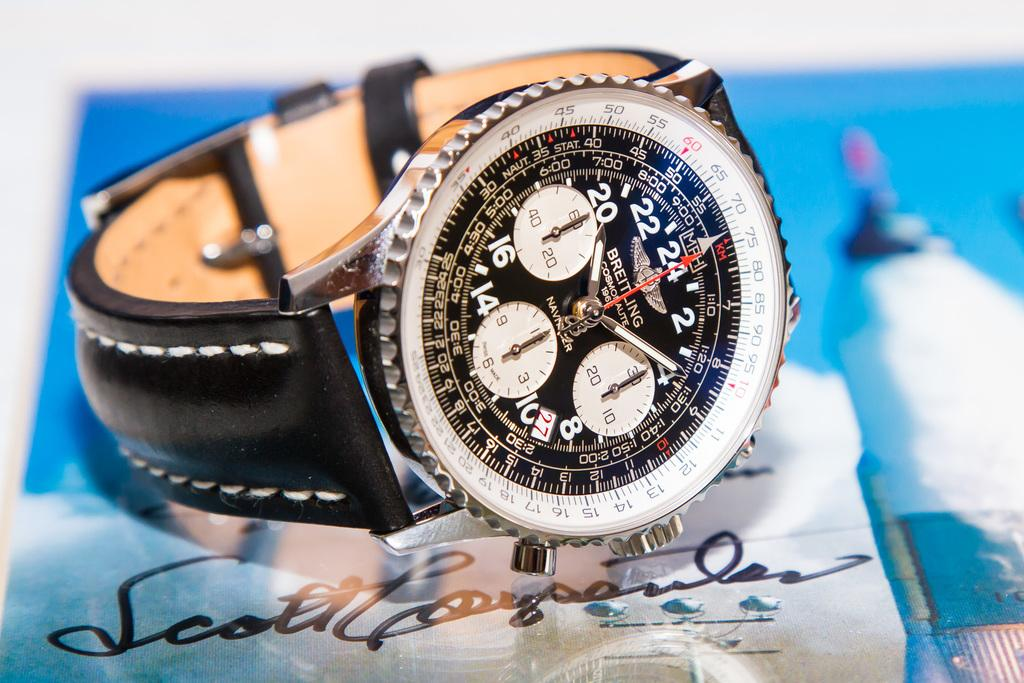<image>
Render a clear and concise summary of the photo. A black and white watch by breitling placed on top of a signed photo 